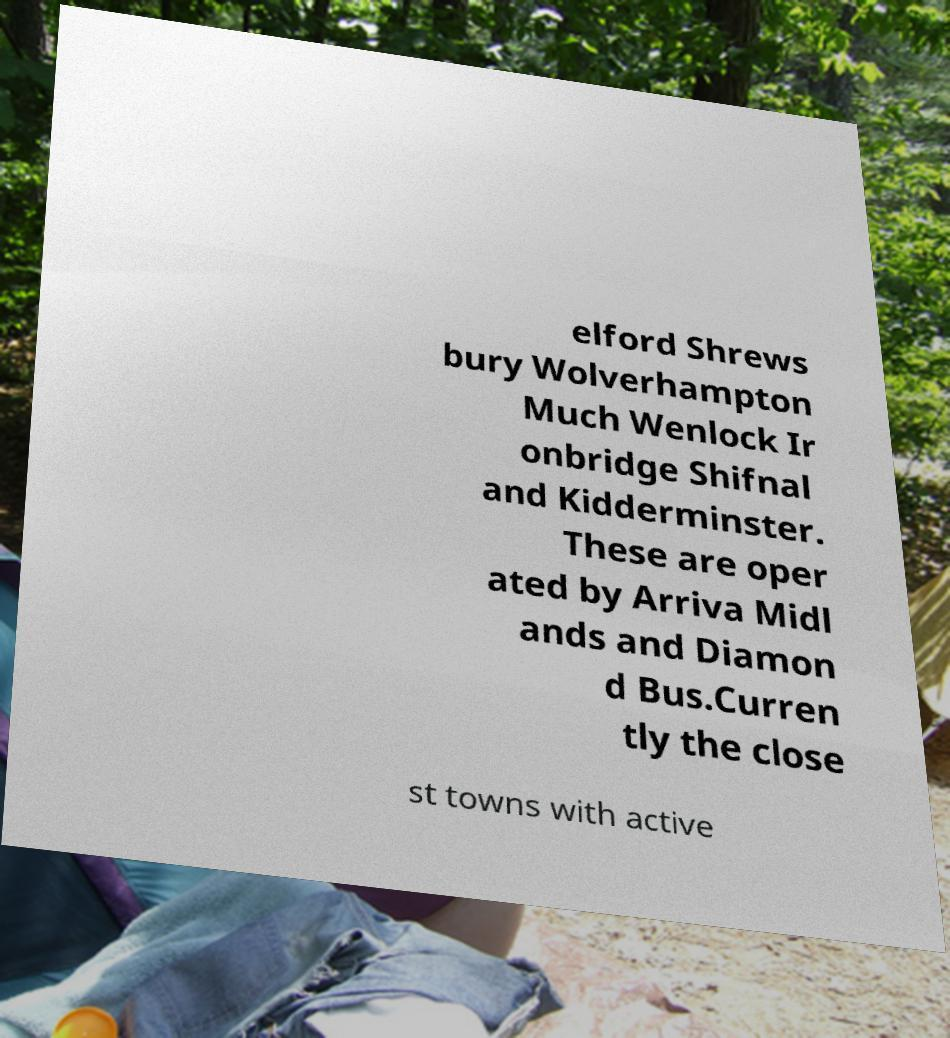I need the written content from this picture converted into text. Can you do that? elford Shrews bury Wolverhampton Much Wenlock Ir onbridge Shifnal and Kidderminster. These are oper ated by Arriva Midl ands and Diamon d Bus.Curren tly the close st towns with active 